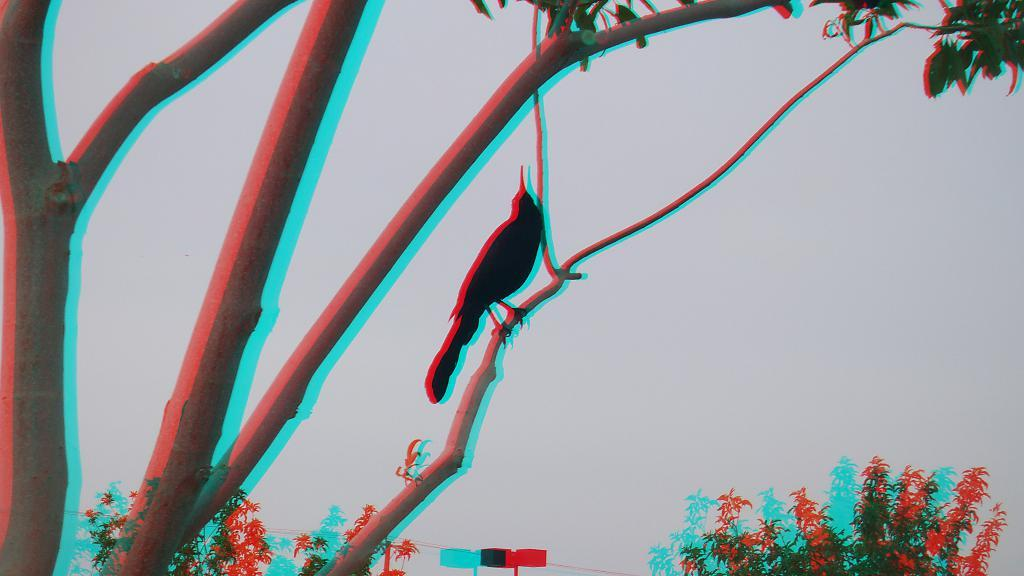What type of vegetation is present in the image? There are trees in the image. What animal can be seen in the image? There is a bird in the image. What part of the trees is visible in the image? Tree branches are visible in the image. What colors are predominant in the image? The image has red and blue colors. What kind of trouble is the bird causing in the image? There is no indication of trouble or any negative actions in the image; the bird is simply present among the trees. How many brothers does the bird have in the image? There is no information about the bird's family or siblings in the image. 